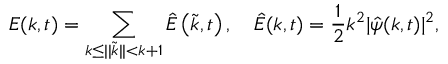<formula> <loc_0><loc_0><loc_500><loc_500>E ( k , t ) = \sum _ { k \leq | | \widetilde { k } | | < { k + 1 } } \hat { E } \left ( \widetilde { k } , t \right ) , \quad \hat { E } ( k , t ) = \frac { 1 } { 2 } k ^ { 2 } | \hat { \psi } ( k , t ) | ^ { 2 } ,</formula> 